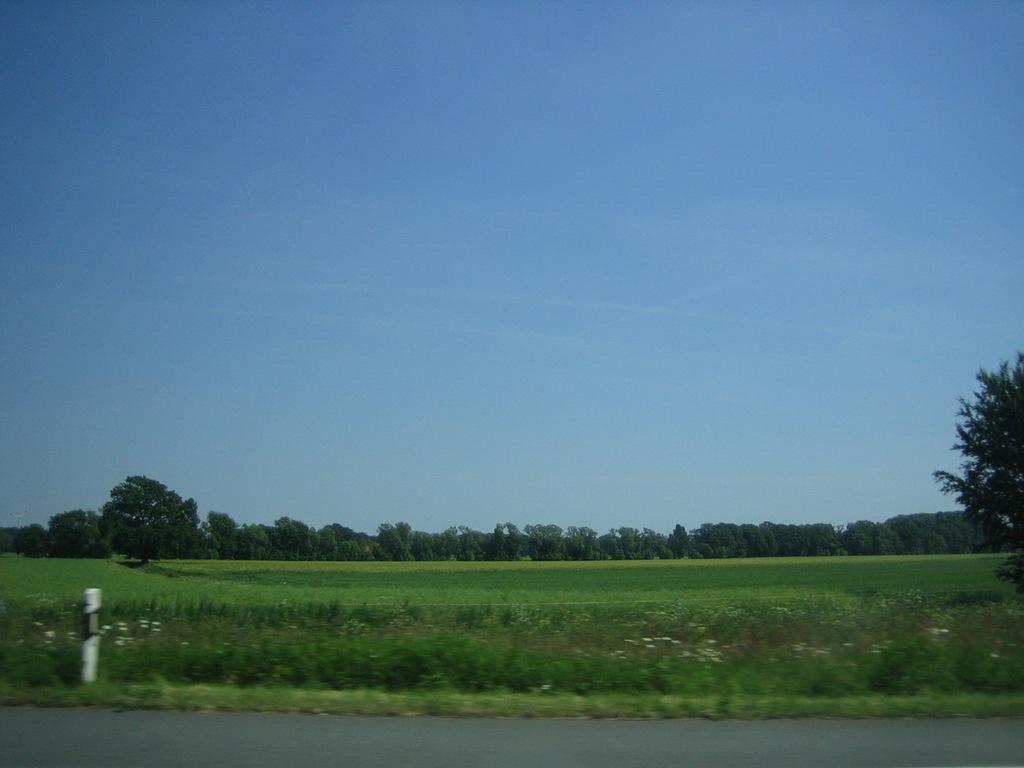What type of surface can be seen in the image? There is a road in the image. What object is present near the road? There is a pole in the image. What type of vegetation is visible in the image? There are plants, grass, and trees in the image. What part of the natural environment is visible in the image? The sky is visible in the background of the image. What type of pancake can be seen smashed on the road in the image? There is no pancake present in the image, and therefore no such activity can be observed. 